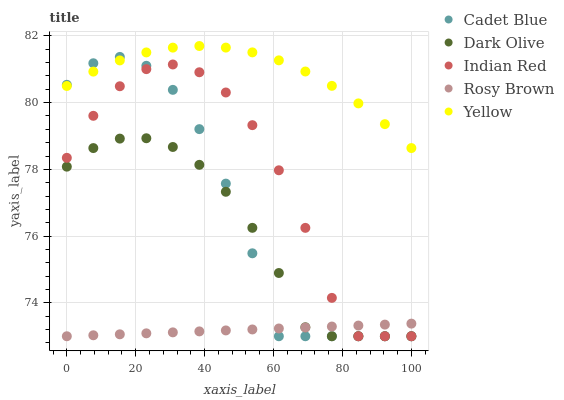Does Rosy Brown have the minimum area under the curve?
Answer yes or no. Yes. Does Yellow have the maximum area under the curve?
Answer yes or no. Yes. Does Cadet Blue have the minimum area under the curve?
Answer yes or no. No. Does Cadet Blue have the maximum area under the curve?
Answer yes or no. No. Is Rosy Brown the smoothest?
Answer yes or no. Yes. Is Cadet Blue the roughest?
Answer yes or no. Yes. Is Cadet Blue the smoothest?
Answer yes or no. No. Is Rosy Brown the roughest?
Answer yes or no. No. Does Dark Olive have the lowest value?
Answer yes or no. Yes. Does Yellow have the lowest value?
Answer yes or no. No. Does Yellow have the highest value?
Answer yes or no. Yes. Does Cadet Blue have the highest value?
Answer yes or no. No. Is Rosy Brown less than Yellow?
Answer yes or no. Yes. Is Yellow greater than Rosy Brown?
Answer yes or no. Yes. Does Indian Red intersect Dark Olive?
Answer yes or no. Yes. Is Indian Red less than Dark Olive?
Answer yes or no. No. Is Indian Red greater than Dark Olive?
Answer yes or no. No. Does Rosy Brown intersect Yellow?
Answer yes or no. No. 